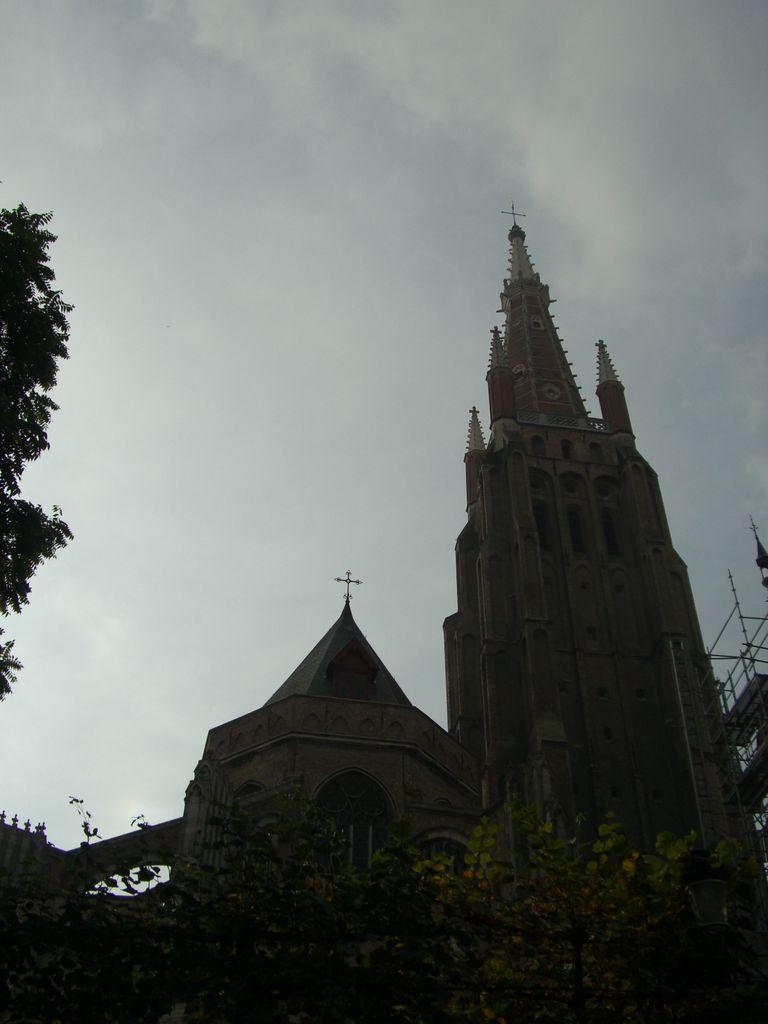How many churches can be seen in the image? There are two churches in the image. What is located around the churches in the image? There are trees around the churches in the image. What type of nut is being used to shock the trees in the image? There is no nut or shocking activity present in the image; it features two churches surrounded by trees. 